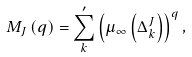<formula> <loc_0><loc_0><loc_500><loc_500>M _ { J } \left ( q \right ) = \sum _ { k } ^ { \prime } \left ( \mu _ { \infty } \left ( \Delta _ { k } ^ { J } \right ) \right ) ^ { q } ,</formula> 